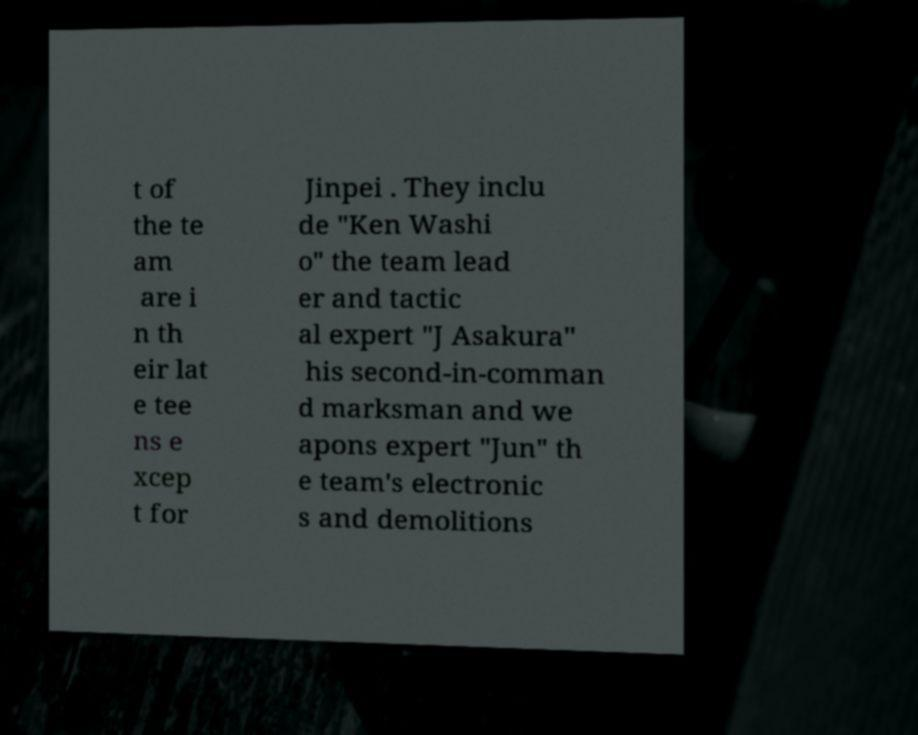There's text embedded in this image that I need extracted. Can you transcribe it verbatim? t of the te am are i n th eir lat e tee ns e xcep t for Jinpei . They inclu de "Ken Washi o" the team lead er and tactic al expert "J Asakura" his second-in-comman d marksman and we apons expert "Jun" th e team's electronic s and demolitions 